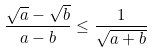<formula> <loc_0><loc_0><loc_500><loc_500>\frac { \sqrt { a } - \sqrt { b } } { a - b } \leq \frac { 1 } { \sqrt { a + b } }</formula> 